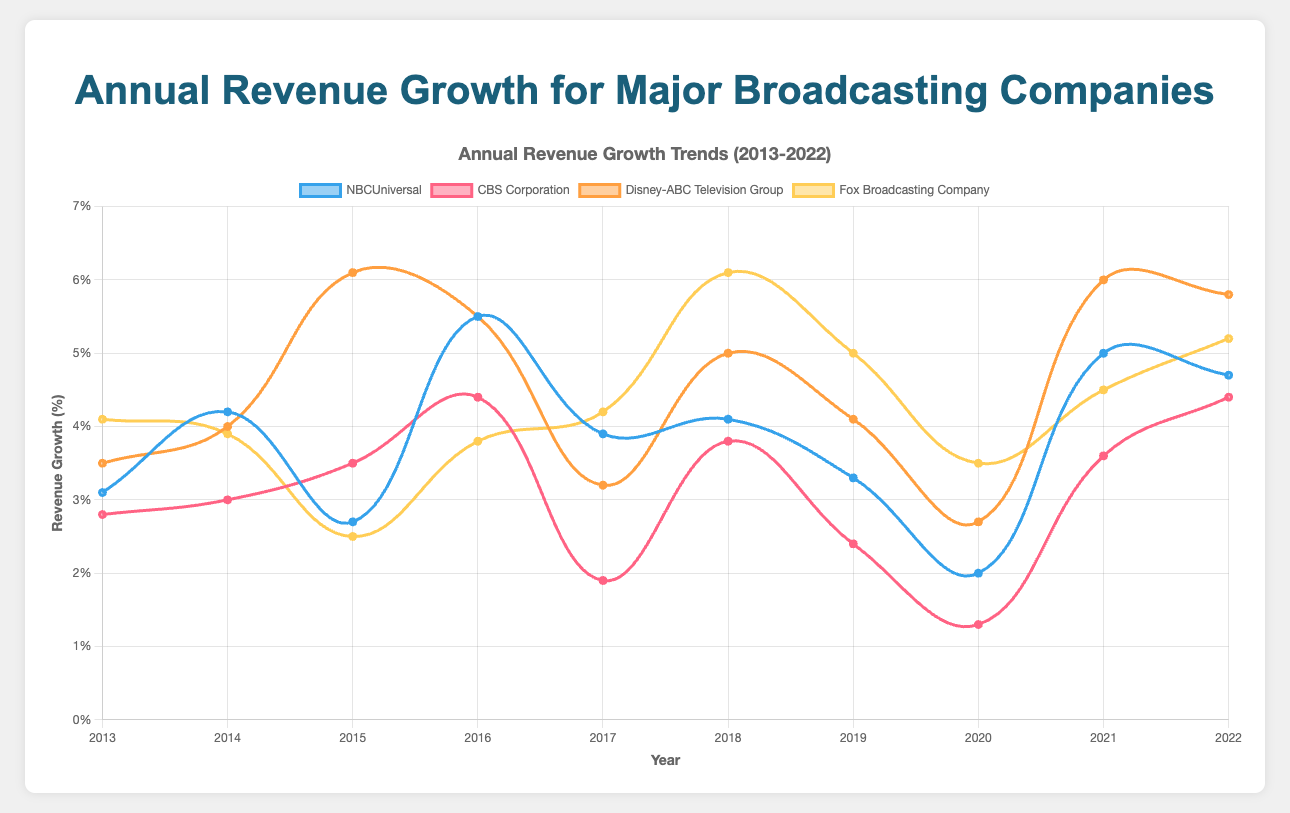What's the highest annual revenue growth percentage for Disney-ABC Television Group within the past decade? Look for the peak point on the curve representing Disney-ABC Television Group. The highest point is in 2015 with a 6.1% growth.
Answer: 6.1% Which company had the lowest growth in 2020? Examine the data points for each company in the year 2020. CBS Corporation had the lowest growth with 1.3%.
Answer: CBS Corporation In which year did NBCUniversal experience its highest revenue growth? Follow the trend line for NBCUniversal and identify the peak. The highest revenue growth was in 2016 at 5.5%.
Answer: 2016 Compare the revenue growth of Fox Broadcasting Company and NBCUniversal in 2018. Which one had higher growth? Look at the data points for 2018 for both companies. Fox Broadcasting Company had a growth of 6.1%, and NBCUniversal had 4.1%. Fox Broadcasting Company had higher growth.
Answer: Fox Broadcasting Company By how much did CBS Corporation's revenue growth change from 2017 to 2018? Subtract the revenue growth in 2017 from the growth in 2018 for CBS Corporation. The change is 3.8% - 1.9% = 1.9%.
Answer: 1.9% What's the average annual revenue growth for NBCUniversal over the decade? Sum the growth percentages of NBCUniversal over the years and divide by the number of years (10). The total is 3.1% + 4.2% + 2.7% + 5.5% + 3.9% + 4.1% + 3.3% + 2.0% + 5.0% + 4.7% = 38.5%, so the average is 38.5% / 10 = 3.85%.
Answer: 3.85% Which two companies had intersecting revenue growth values, and in which year did they intersect? Find overlapping points on the chart. NBCUniversal and Disney-ABC Television Group both had 5.5% revenue growth in 2016.
Answer: NBCUniversal, Disney-ABC Television Group, 2016 Calculate the overall average revenue growth for all companies in 2022. Add the revenue growth percentages of all companies for 2022 and divide by the number of companies (4). The values are 4.7% (NBCUniversal), 4.4% (CBS Corporation), 5.8% (Disney-ABC Television Group), 5.2% (Fox Broadcasting Company). The total is 20.1%, so the average is 20.1% / 4 = 5.025%.
Answer: 5.025% Compare the trend of revenue growth for Disney-ABC Television Group and CBS Corporation from 2013 to 2022. Which one shows a more consistent upward trend? Observe the smoothing curves for both companies across the decade. The Disney-ABC Television Group shows a consistently higher overall growth compared to CBS Corporation, which shows more fluctuations.
Answer: Disney-ABC Television Group When did Fox Broadcasting Company see a significant jump in revenue growth and by how much? Identify the year with a sudden increase on the Fox Broadcasting Company trend. Between 2017 and 2018, the growth jumps from 4.2% to 6.1%. The difference is 6.1% - 4.2% = 1.9%.
Answer: 2018, 1.9% 